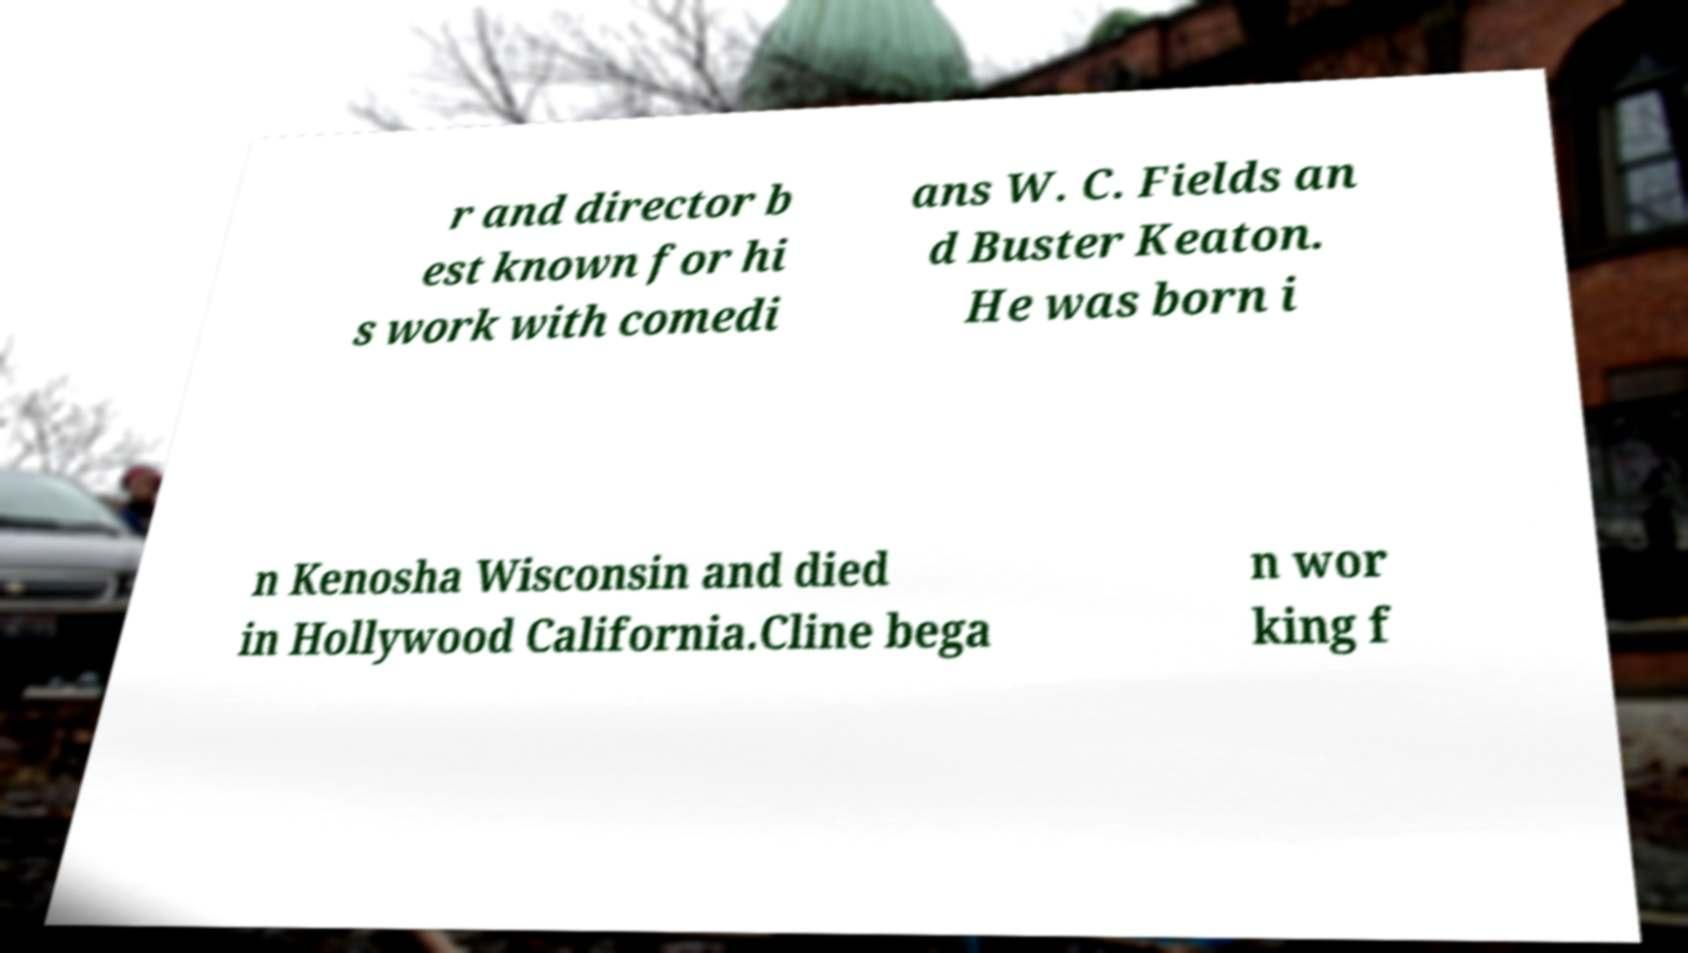There's text embedded in this image that I need extracted. Can you transcribe it verbatim? r and director b est known for hi s work with comedi ans W. C. Fields an d Buster Keaton. He was born i n Kenosha Wisconsin and died in Hollywood California.Cline bega n wor king f 